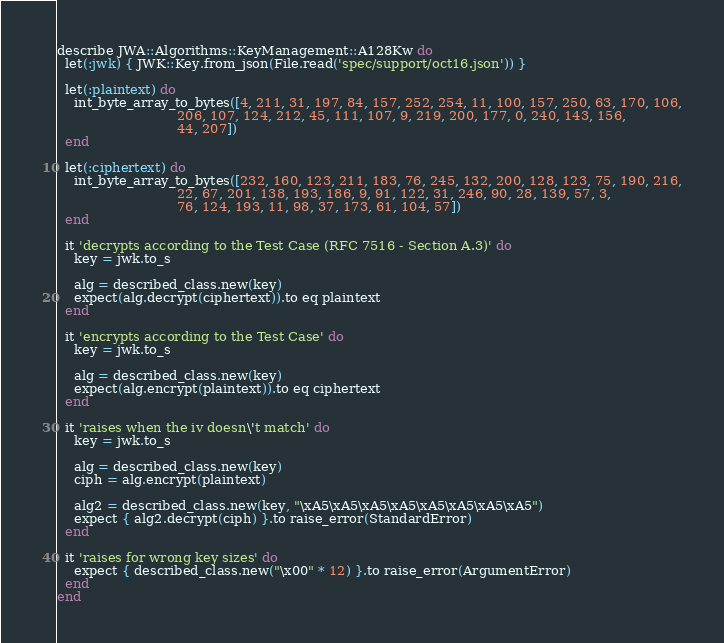<code> <loc_0><loc_0><loc_500><loc_500><_Ruby_>describe JWA::Algorithms::KeyManagement::A128Kw do
  let(:jwk) { JWK::Key.from_json(File.read('spec/support/oct16.json')) }

  let(:plaintext) do
    int_byte_array_to_bytes([4, 211, 31, 197, 84, 157, 252, 254, 11, 100, 157, 250, 63, 170, 106,
                             206, 107, 124, 212, 45, 111, 107, 9, 219, 200, 177, 0, 240, 143, 156,
                             44, 207])
  end

  let(:ciphertext) do
    int_byte_array_to_bytes([232, 160, 123, 211, 183, 76, 245, 132, 200, 128, 123, 75, 190, 216,
                             22, 67, 201, 138, 193, 186, 9, 91, 122, 31, 246, 90, 28, 139, 57, 3,
                             76, 124, 193, 11, 98, 37, 173, 61, 104, 57])
  end

  it 'decrypts according to the Test Case (RFC 7516 - Section A.3)' do
    key = jwk.to_s

    alg = described_class.new(key)
    expect(alg.decrypt(ciphertext)).to eq plaintext
  end

  it 'encrypts according to the Test Case' do
    key = jwk.to_s

    alg = described_class.new(key)
    expect(alg.encrypt(plaintext)).to eq ciphertext
  end

  it 'raises when the iv doesn\'t match' do
    key = jwk.to_s

    alg = described_class.new(key)
    ciph = alg.encrypt(plaintext)

    alg2 = described_class.new(key, "\xA5\xA5\xA5\xA5\xA5\xA5\xA5\xA5")
    expect { alg2.decrypt(ciph) }.to raise_error(StandardError)
  end

  it 'raises for wrong key sizes' do
    expect { described_class.new("\x00" * 12) }.to raise_error(ArgumentError)
  end
end
</code> 